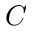<formula> <loc_0><loc_0><loc_500><loc_500>C</formula> 